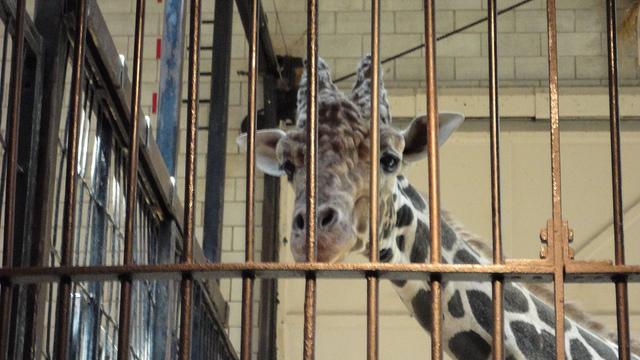Why is the giraffe behind bars?
Concise answer only. In zoo. How many giraffes are there?
Write a very short answer. 1. Is the giraffe locked up?
Write a very short answer. Yes. What is looking at you?
Give a very brief answer. Giraffe. 